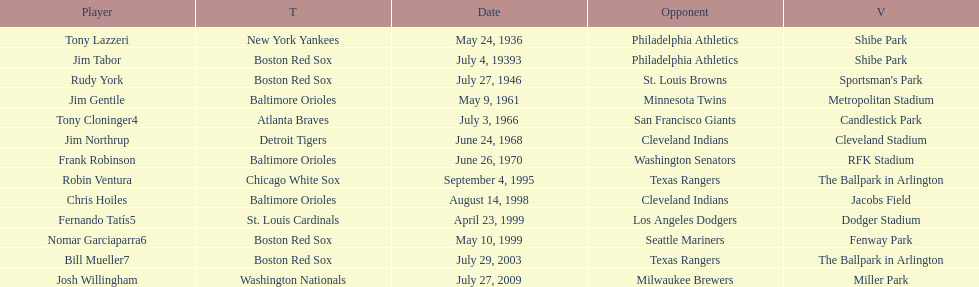On what date did the detroit tigers play the cleveland indians? June 24, 1968. Could you help me parse every detail presented in this table? {'header': ['Player', 'T', 'Date', 'Opponent', 'V'], 'rows': [['Tony Lazzeri', 'New York Yankees', 'May 24, 1936', 'Philadelphia Athletics', 'Shibe Park'], ['Jim Tabor', 'Boston Red Sox', 'July 4, 19393', 'Philadelphia Athletics', 'Shibe Park'], ['Rudy York', 'Boston Red Sox', 'July 27, 1946', 'St. Louis Browns', "Sportsman's Park"], ['Jim Gentile', 'Baltimore Orioles', 'May 9, 1961', 'Minnesota Twins', 'Metropolitan Stadium'], ['Tony Cloninger4', 'Atlanta Braves', 'July 3, 1966', 'San Francisco Giants', 'Candlestick Park'], ['Jim Northrup', 'Detroit Tigers', 'June 24, 1968', 'Cleveland Indians', 'Cleveland Stadium'], ['Frank Robinson', 'Baltimore Orioles', 'June 26, 1970', 'Washington Senators', 'RFK Stadium'], ['Robin Ventura', 'Chicago White Sox', 'September 4, 1995', 'Texas Rangers', 'The Ballpark in Arlington'], ['Chris Hoiles', 'Baltimore Orioles', 'August 14, 1998', 'Cleveland Indians', 'Jacobs Field'], ['Fernando Tatís5', 'St. Louis Cardinals', 'April 23, 1999', 'Los Angeles Dodgers', 'Dodger Stadium'], ['Nomar Garciaparra6', 'Boston Red Sox', 'May 10, 1999', 'Seattle Mariners', 'Fenway Park'], ['Bill Mueller7', 'Boston Red Sox', 'July 29, 2003', 'Texas Rangers', 'The Ballpark in Arlington'], ['Josh Willingham', 'Washington Nationals', 'July 27, 2009', 'Milwaukee Brewers', 'Miller Park']]} 